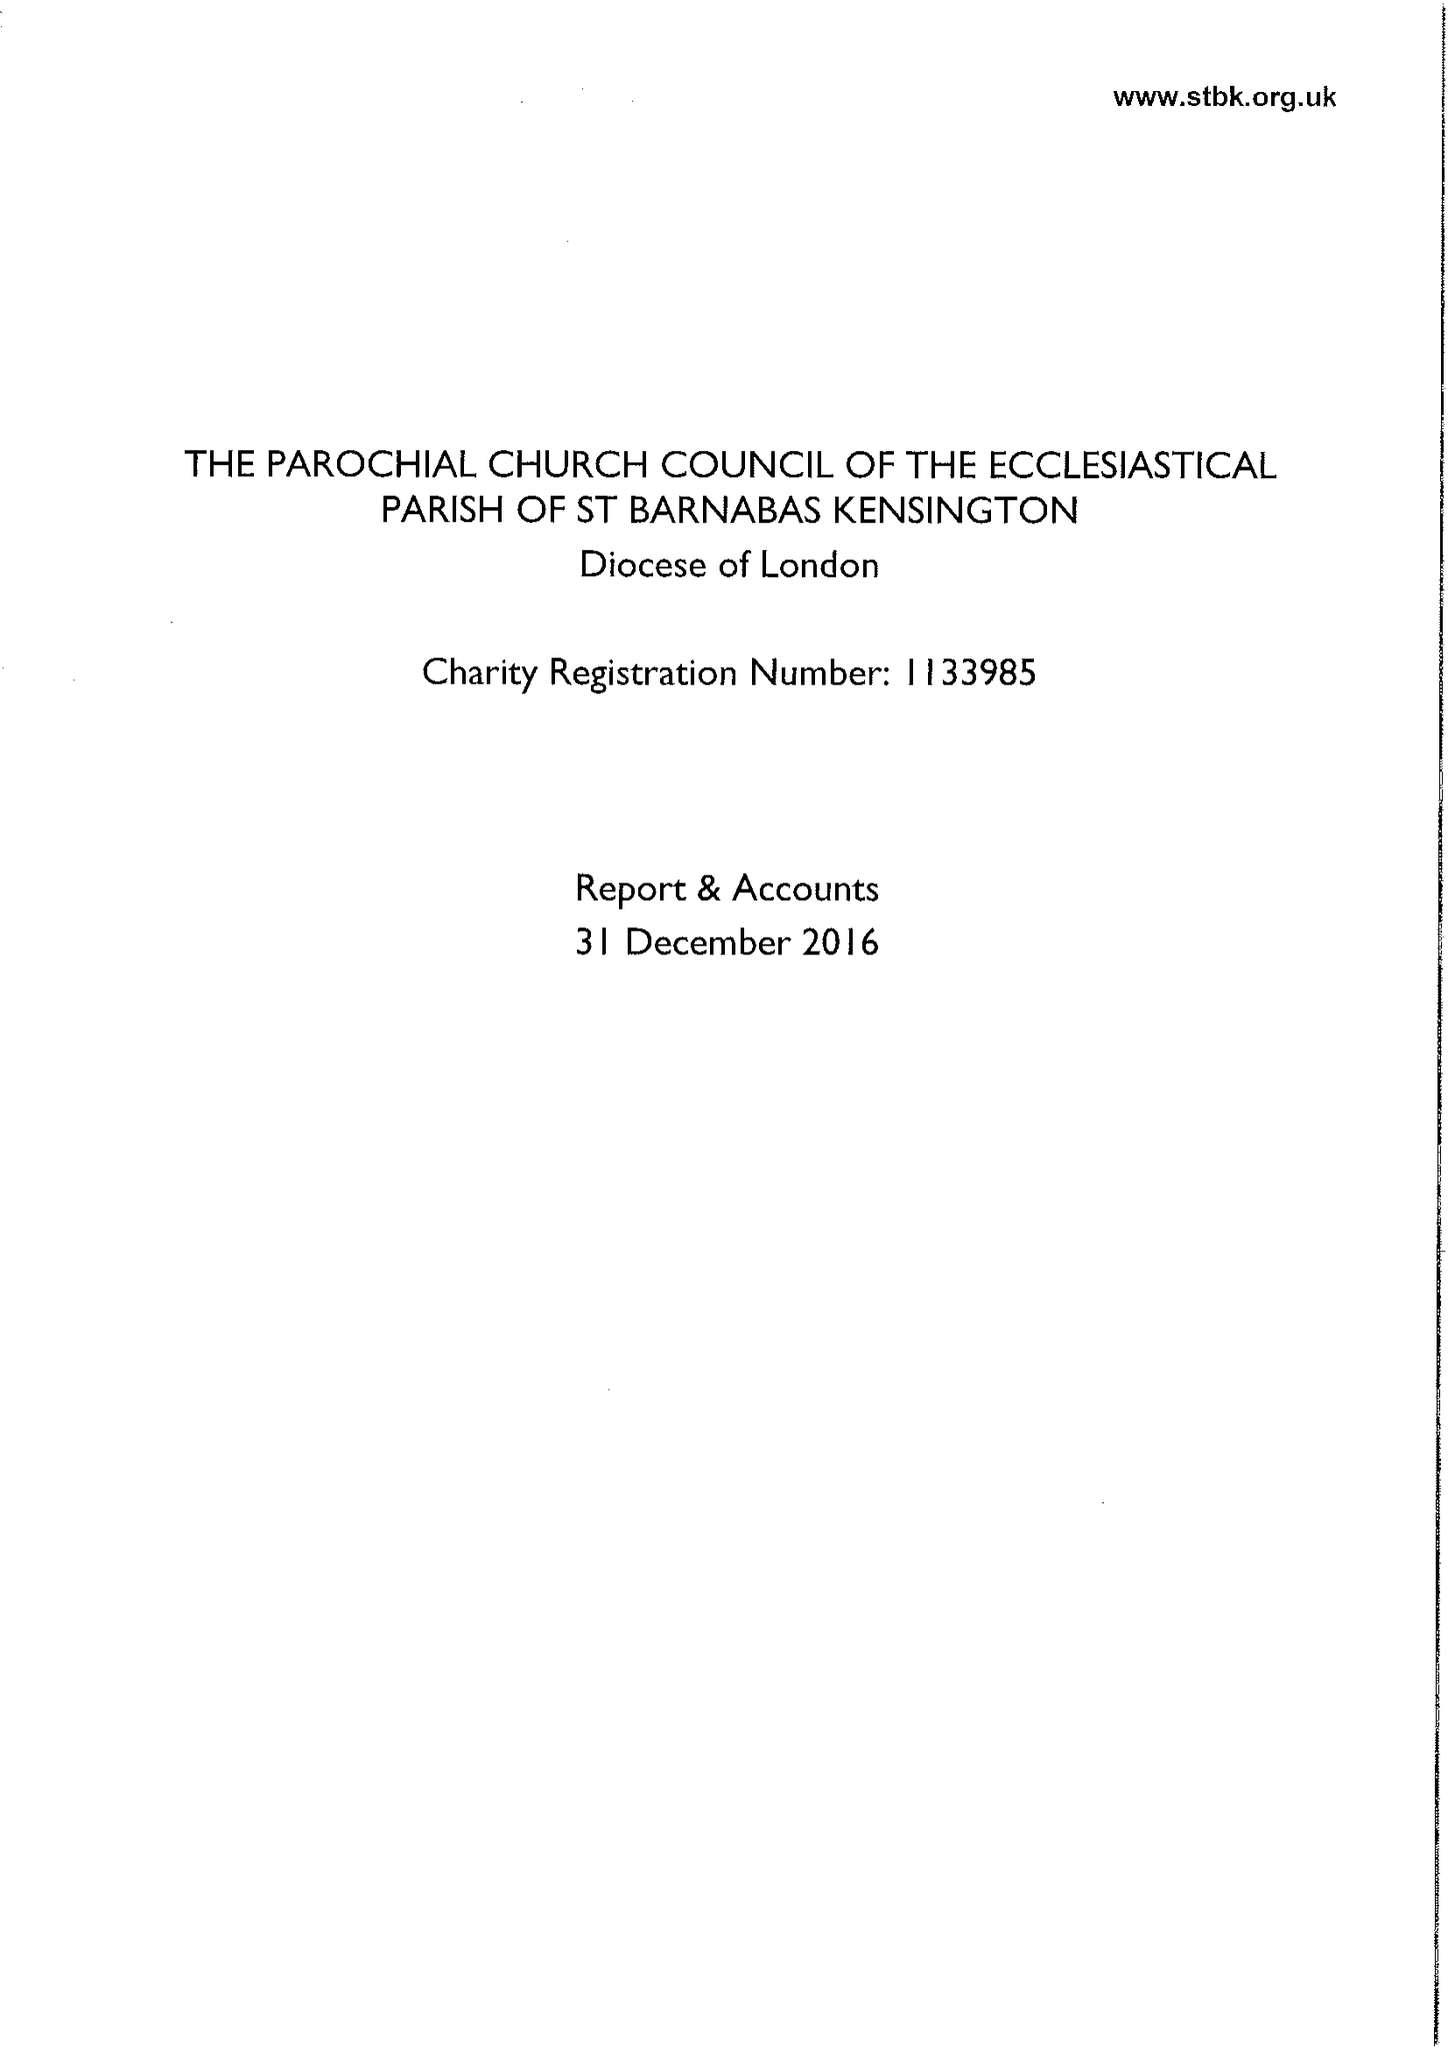What is the value for the report_date?
Answer the question using a single word or phrase. 2016-12-31 